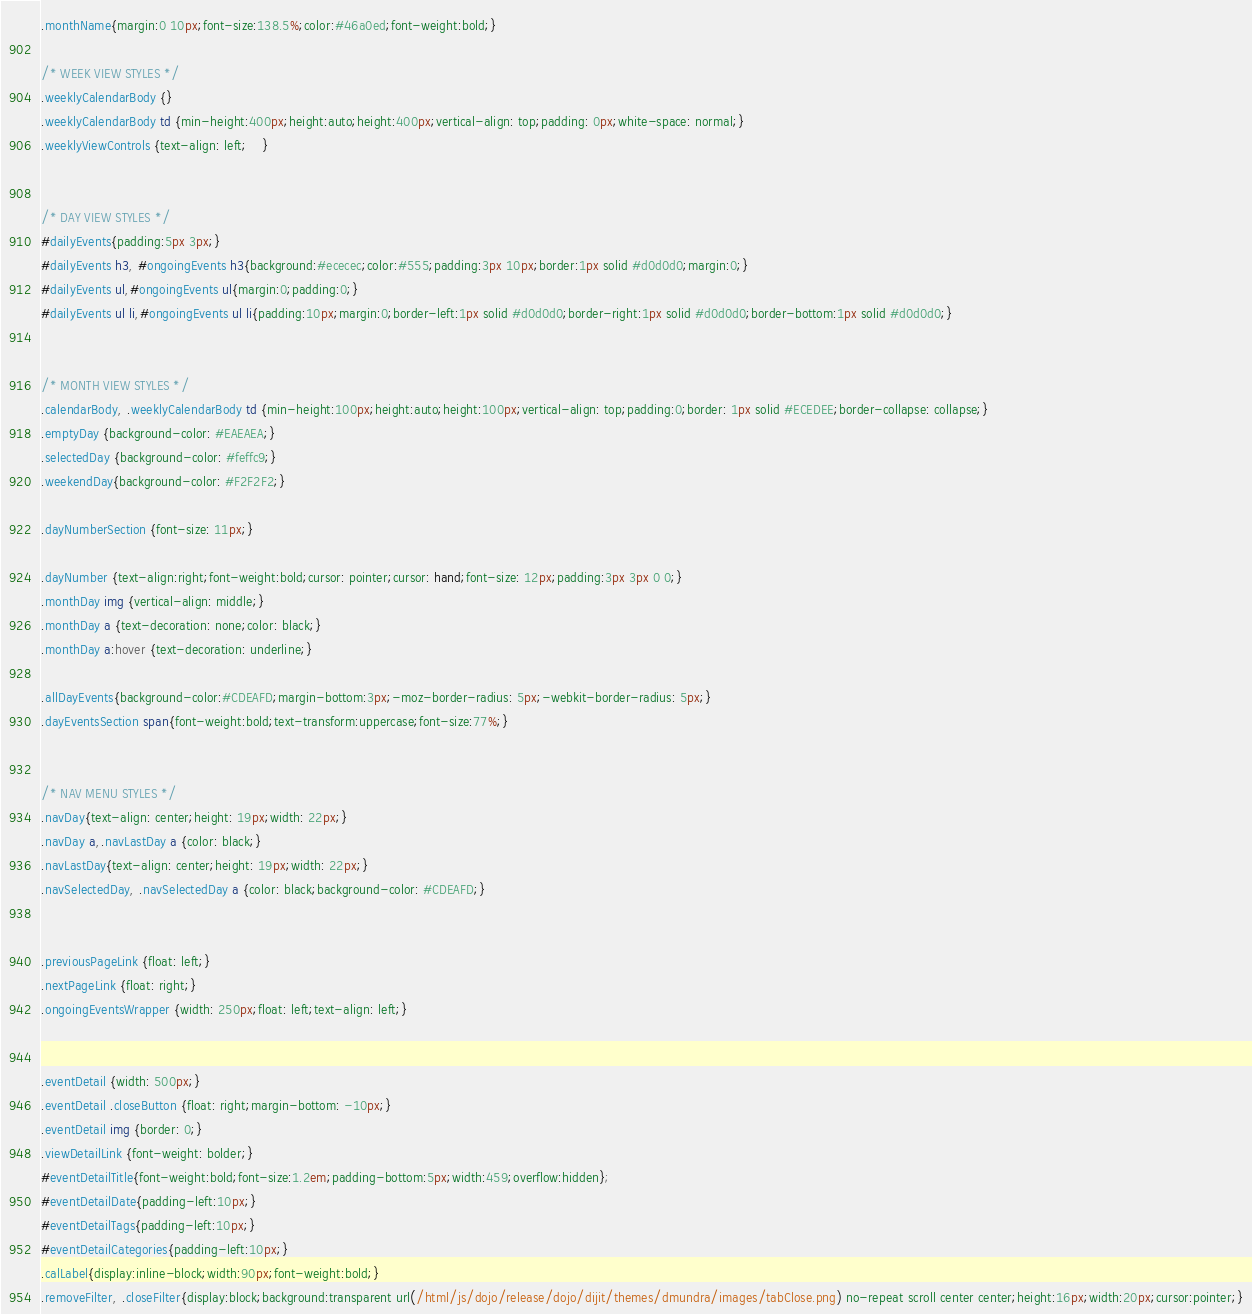Convert code to text. <code><loc_0><loc_0><loc_500><loc_500><_CSS_>.monthName{margin:0 10px;font-size:138.5%;color:#46a0ed;font-weight:bold;}

/* WEEK VIEW STYLES */
.weeklyCalendarBody {}
.weeklyCalendarBody td {min-height:400px;height:auto;height:400px;vertical-align: top;padding: 0px;white-space: normal;}
.weeklyViewControls {text-align: left;	}


/* DAY VIEW STYLES */
#dailyEvents{padding:5px 3px;}
#dailyEvents h3, #ongoingEvents h3{background:#ececec;color:#555;padding:3px 10px;border:1px solid #d0d0d0;margin:0;}
#dailyEvents ul,#ongoingEvents ul{margin:0;padding:0;}
#dailyEvents ul li,#ongoingEvents ul li{padding:10px;margin:0;border-left:1px solid #d0d0d0;border-right:1px solid #d0d0d0;border-bottom:1px solid #d0d0d0;}


/* MONTH VIEW STYLES */
.calendarBody, .weeklyCalendarBody td {min-height:100px;height:auto;height:100px;vertical-align: top;padding:0;border: 1px solid #ECEDEE;border-collapse: collapse;}
.emptyDay {background-color: #EAEAEA;}
.selectedDay {background-color: #feffc9;}
.weekendDay{background-color: #F2F2F2;}

.dayNumberSection {font-size: 11px;}

.dayNumber {text-align:right;font-weight:bold;cursor: pointer;cursor: hand;font-size: 12px;padding:3px 3px 0 0;}
.monthDay img {vertical-align: middle;}
.monthDay a {text-decoration: none;color: black;}
.monthDay a:hover {text-decoration: underline;}

.allDayEvents{background-color:#CDEAFD;margin-bottom:3px;-moz-border-radius: 5px;-webkit-border-radius: 5px;}
.dayEventsSection span{font-weight:bold;text-transform:uppercase;font-size:77%;}


/* NAV MENU STYLES */
.navDay{text-align: center;height: 19px;width: 22px;}
.navDay a,.navLastDay a {color: black;}
.navLastDay{text-align: center;height: 19px;width: 22px;}
.navSelectedDay, .navSelectedDay a {color: black;background-color: #CDEAFD;}


.previousPageLink {float: left;}
.nextPageLink {float: right;}
.ongoingEventsWrapper {width: 250px;float: left;text-align: left;}


.eventDetail {width: 500px;}
.eventDetail .closeButton {float: right;margin-bottom: -10px;}
.eventDetail img {border: 0;}	
.viewDetailLink {font-weight: bolder;}
#eventDetailTitle{font-weight:bold;font-size:1.2em;padding-bottom:5px;width:459;overflow:hidden};
#eventDetailDate{padding-left:10px;}
#eventDetailTags{padding-left:10px;}
#eventDetailCategories{padding-left:10px;}
.calLabel{display:inline-block;width:90px;font-weight:bold;}
.removeFilter, .closeFilter{display:block;background:transparent url(/html/js/dojo/release/dojo/dijit/themes/dmundra/images/tabClose.png) no-repeat scroll center center;height:16px;width:20px;cursor:pointer;}</code> 